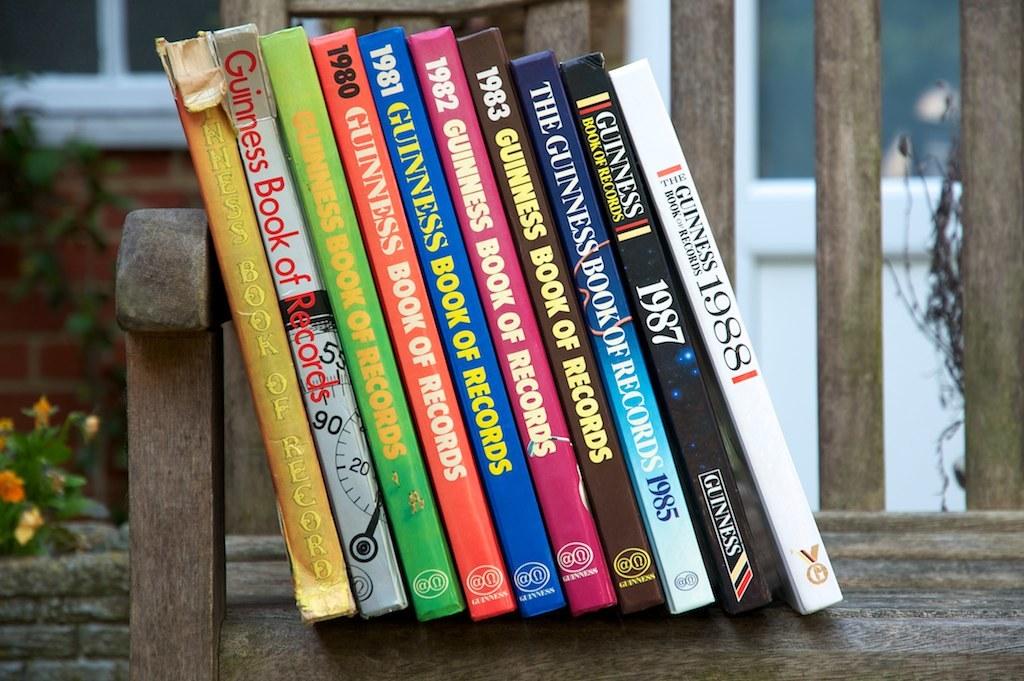What is the latest year of records recorded in these books?
Give a very brief answer. 1988. What is the title of the left book?
Offer a terse response. Guiness book of records. 